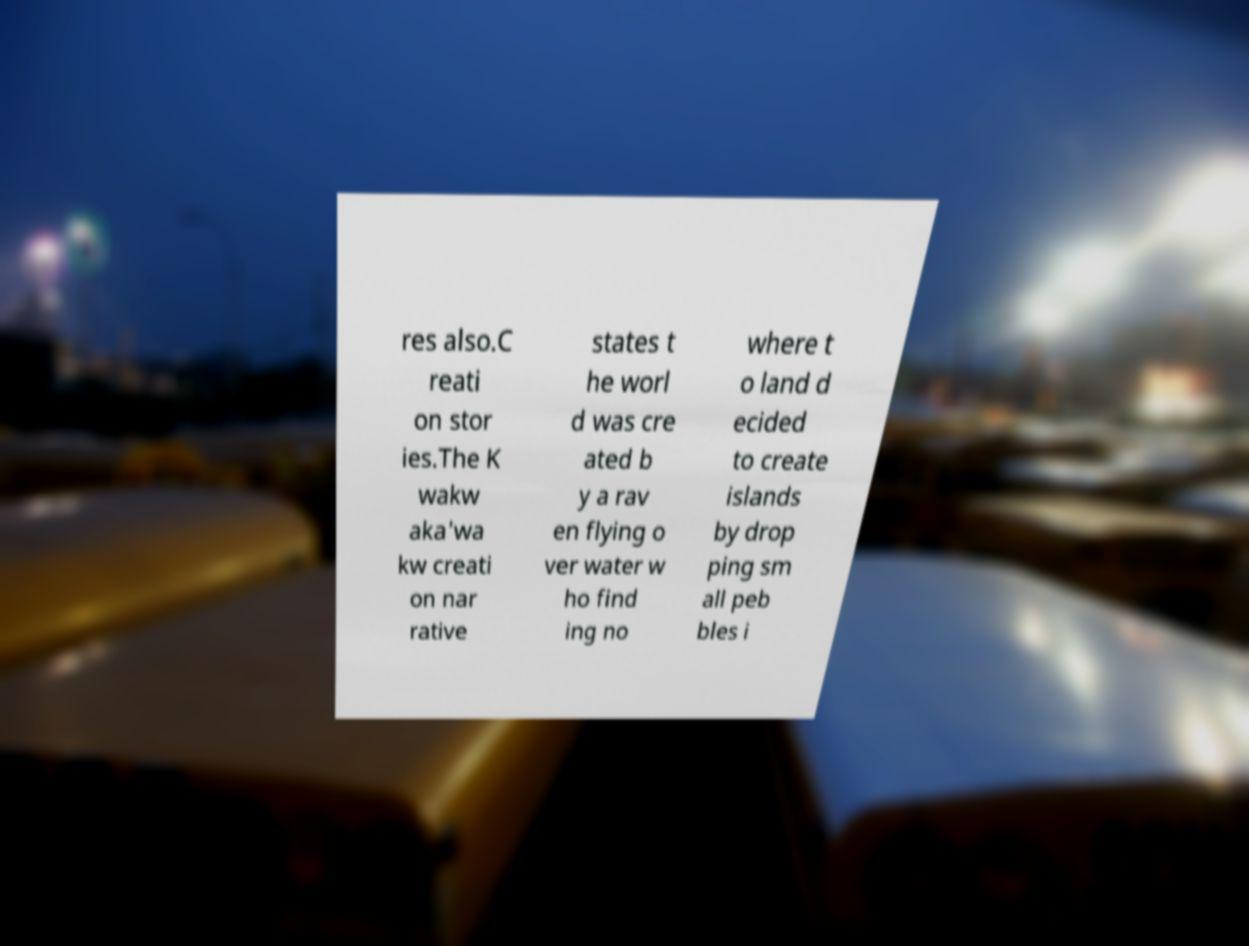Could you assist in decoding the text presented in this image and type it out clearly? res also.C reati on stor ies.The K wakw aka'wa kw creati on nar rative states t he worl d was cre ated b y a rav en flying o ver water w ho find ing no where t o land d ecided to create islands by drop ping sm all peb bles i 